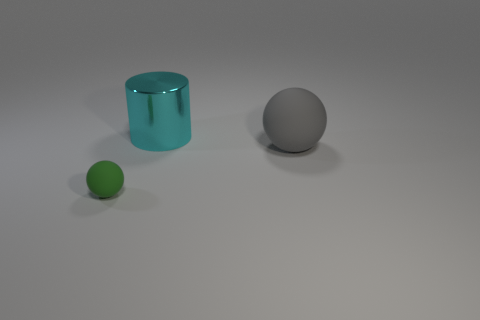Is there any other thing that has the same size as the green ball?
Provide a short and direct response. No. There is a matte ball that is to the right of the green rubber object; does it have the same size as the cyan thing?
Your answer should be compact. Yes. The thing that is to the right of the small green sphere and left of the large gray matte sphere is what color?
Ensure brevity in your answer.  Cyan. What is the material of the big cyan thing?
Provide a succinct answer. Metal. There is a tiny green object that is on the left side of the gray thing; what is its shape?
Provide a short and direct response. Sphere. There is a sphere that is the same size as the cyan cylinder; what color is it?
Ensure brevity in your answer.  Gray. Does the sphere on the right side of the big metallic thing have the same material as the big cyan object?
Make the answer very short. No. There is a object that is in front of the cylinder and left of the big matte thing; how big is it?
Give a very brief answer. Small. There is a matte sphere to the right of the tiny green sphere; what is its size?
Your response must be concise. Large. The rubber object behind the green matte object in front of the big cyan cylinder behind the small green thing is what shape?
Make the answer very short. Sphere. 